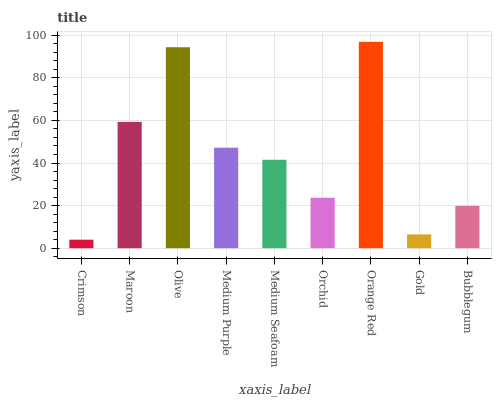Is Crimson the minimum?
Answer yes or no. Yes. Is Orange Red the maximum?
Answer yes or no. Yes. Is Maroon the minimum?
Answer yes or no. No. Is Maroon the maximum?
Answer yes or no. No. Is Maroon greater than Crimson?
Answer yes or no. Yes. Is Crimson less than Maroon?
Answer yes or no. Yes. Is Crimson greater than Maroon?
Answer yes or no. No. Is Maroon less than Crimson?
Answer yes or no. No. Is Medium Seafoam the high median?
Answer yes or no. Yes. Is Medium Seafoam the low median?
Answer yes or no. Yes. Is Orchid the high median?
Answer yes or no. No. Is Orange Red the low median?
Answer yes or no. No. 